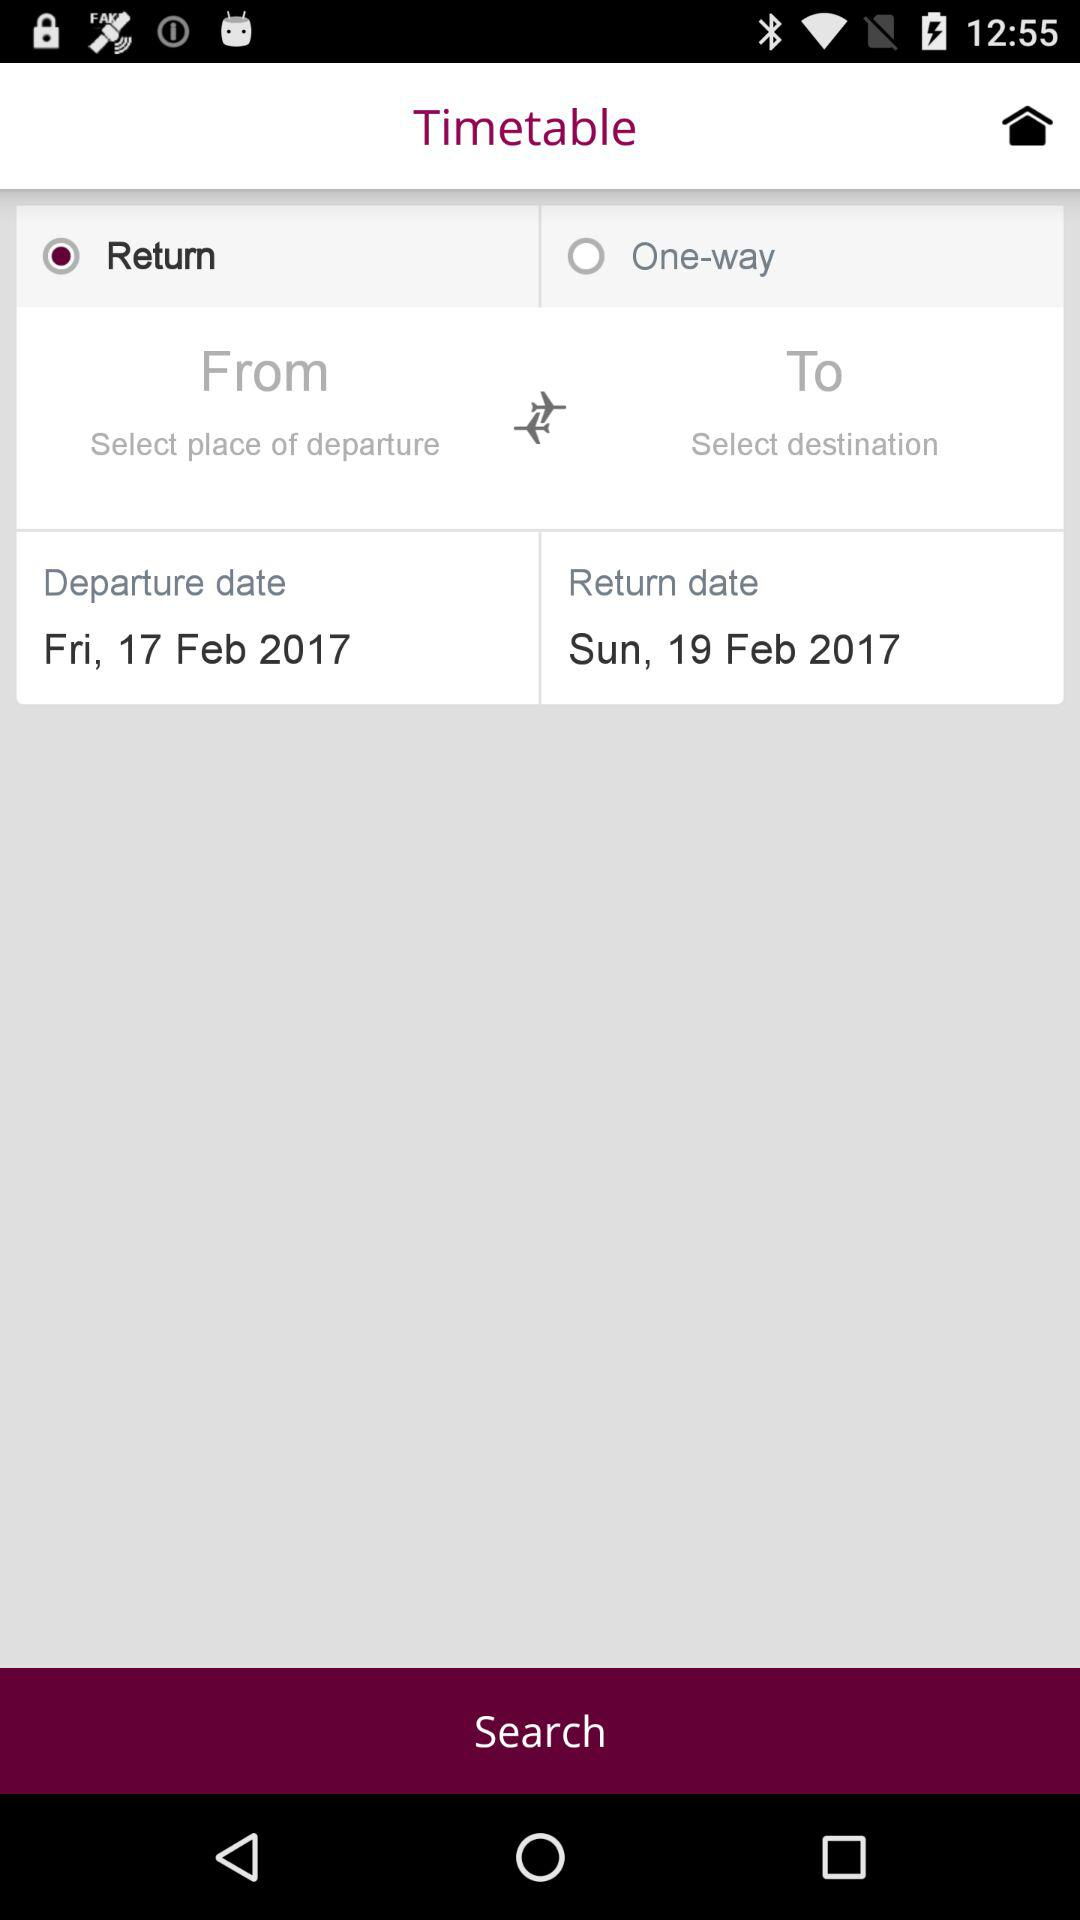How many days are there between the departure and return dates?
Answer the question using a single word or phrase. 2 